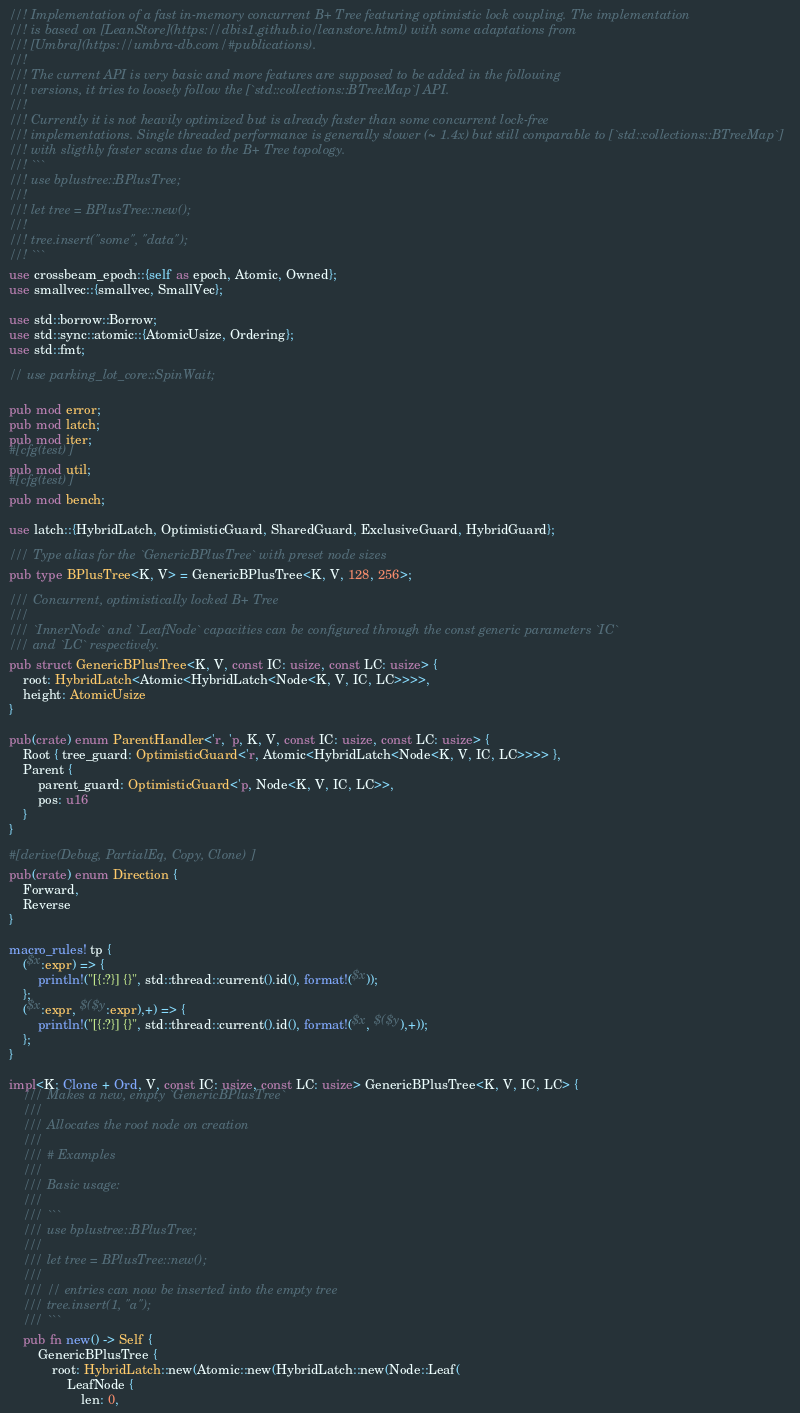<code> <loc_0><loc_0><loc_500><loc_500><_Rust_>//! Implementation of a fast in-memory concurrent B+ Tree featuring optimistic lock coupling. The implementation
//! is based on [LeanStore](https://dbis1.github.io/leanstore.html) with some adaptations from
//! [Umbra](https://umbra-db.com/#publications).
//!
//! The current API is very basic and more features are supposed to be added in the following
//! versions, it tries to loosely follow the [`std::collections::BTreeMap`] API.
//!
//! Currently it is not heavily optimized but is already faster than some concurrent lock-free
//! implementations. Single threaded performance is generally slower (~ 1.4x) but still comparable to [`std::collections::BTreeMap`]
//! with sligthly faster scans due to the B+ Tree topology.
//! ```
//! use bplustree::BPlusTree;
//!
//! let tree = BPlusTree::new();
//!
//! tree.insert("some", "data");
//! ```
use crossbeam_epoch::{self as epoch, Atomic, Owned};
use smallvec::{smallvec, SmallVec};

use std::borrow::Borrow;
use std::sync::atomic::{AtomicUsize, Ordering};
use std::fmt;

// use parking_lot_core::SpinWait;

pub mod error;
pub mod latch;
pub mod iter;
#[cfg(test)]
pub mod util;
#[cfg(test)]
pub mod bench;

use latch::{HybridLatch, OptimisticGuard, SharedGuard, ExclusiveGuard, HybridGuard};

/// Type alias for the `GenericBPlusTree` with preset node sizes
pub type BPlusTree<K, V> = GenericBPlusTree<K, V, 128, 256>;

/// Concurrent, optimistically locked B+ Tree
///
/// `InnerNode` and `LeafNode` capacities can be configured through the const generic parameters `IC`
/// and `LC` respectively.
pub struct GenericBPlusTree<K, V, const IC: usize, const LC: usize> {
    root: HybridLatch<Atomic<HybridLatch<Node<K, V, IC, LC>>>>,
    height: AtomicUsize
}

pub(crate) enum ParentHandler<'r, 'p, K, V, const IC: usize, const LC: usize> {
    Root { tree_guard: OptimisticGuard<'r, Atomic<HybridLatch<Node<K, V, IC, LC>>>> },
    Parent {
        parent_guard: OptimisticGuard<'p, Node<K, V, IC, LC>>,
        pos: u16
    }
}

#[derive(Debug, PartialEq, Copy, Clone)]
pub(crate) enum Direction {
    Forward,
    Reverse
}

macro_rules! tp {
    ($x:expr) => {
        println!("[{:?}] {}", std::thread::current().id(), format!($x));
    };
    ($x:expr, $($y:expr),+) => {
        println!("[{:?}] {}", std::thread::current().id(), format!($x, $($y),+));
    };
}

impl<K: Clone + Ord, V, const IC: usize, const LC: usize> GenericBPlusTree<K, V, IC, LC> {
    /// Makes a new, empty `GenericBPlusTree`
    ///
    /// Allocates the root node on creation
    ///
    /// # Examples
    ///
    /// Basic usage:
    ///
    /// ```
    /// use bplustree::BPlusTree;
    ///
    /// let tree = BPlusTree::new();
    ///
    /// // entries can now be inserted into the empty tree
    /// tree.insert(1, "a");
    /// ```
    pub fn new() -> Self {
        GenericBPlusTree {
            root: HybridLatch::new(Atomic::new(HybridLatch::new(Node::Leaf(
                LeafNode {
                    len: 0,</code> 